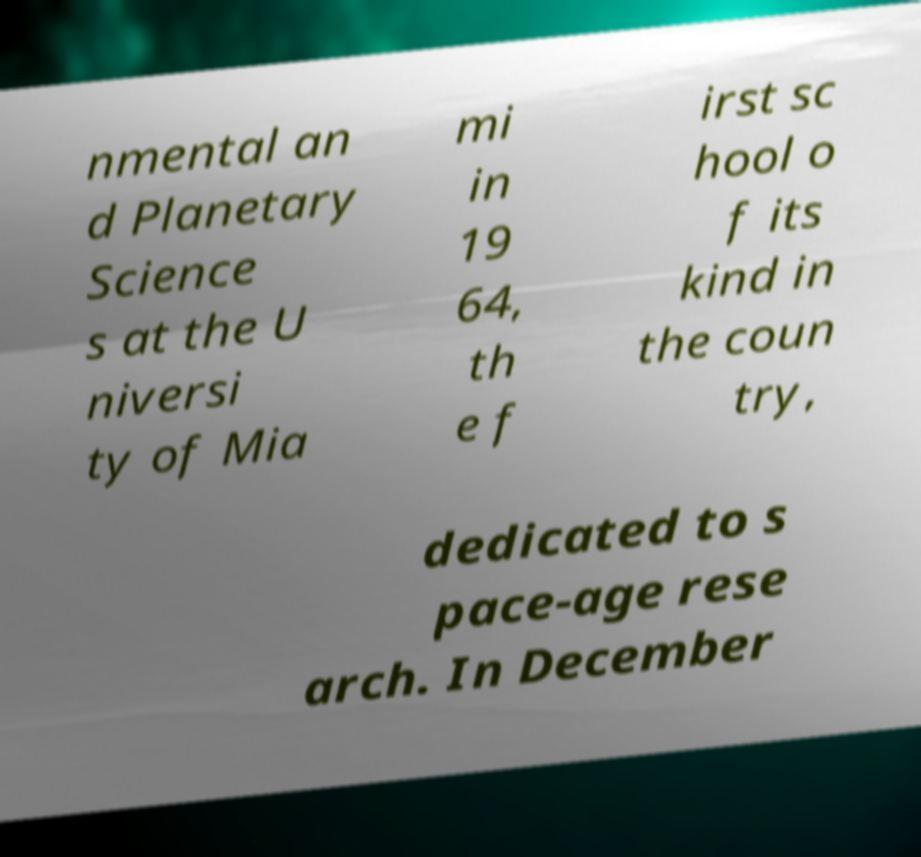Please identify and transcribe the text found in this image. nmental an d Planetary Science s at the U niversi ty of Mia mi in 19 64, th e f irst sc hool o f its kind in the coun try, dedicated to s pace-age rese arch. In December 